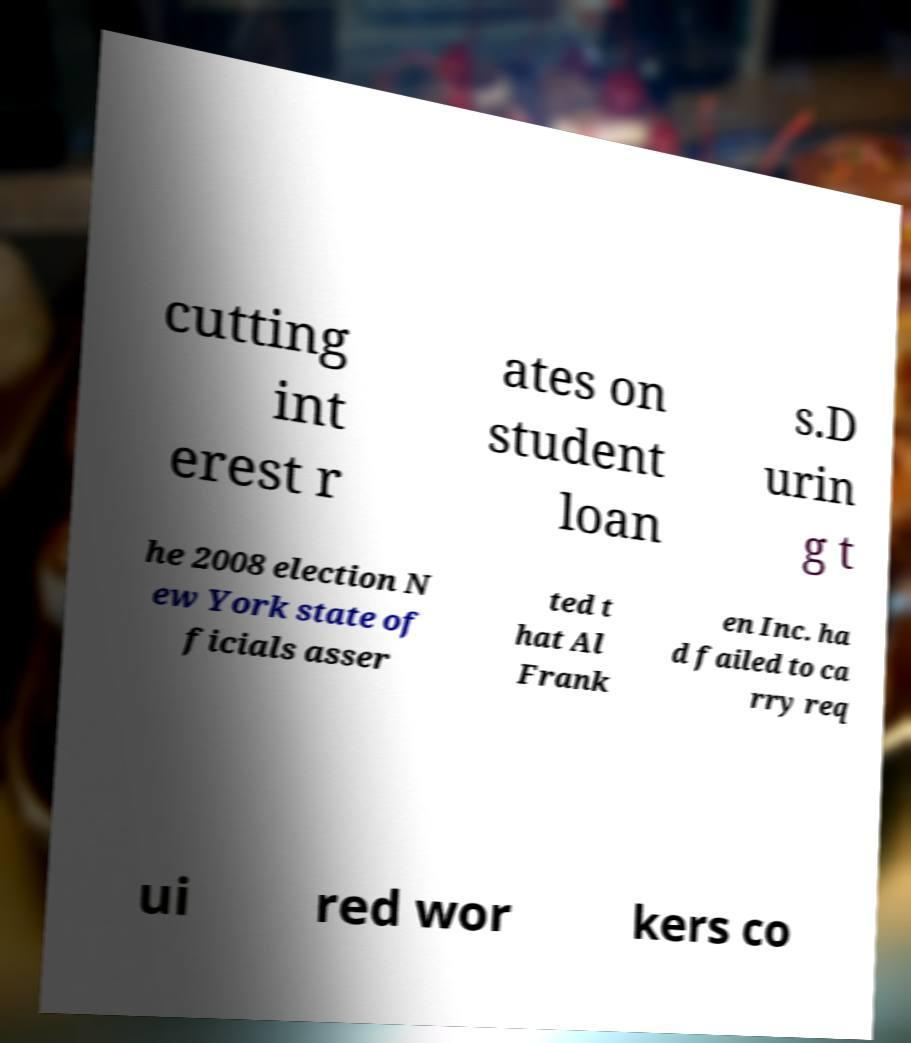Can you read and provide the text displayed in the image?This photo seems to have some interesting text. Can you extract and type it out for me? cutting int erest r ates on student loan s.D urin g t he 2008 election N ew York state of ficials asser ted t hat Al Frank en Inc. ha d failed to ca rry req ui red wor kers co 